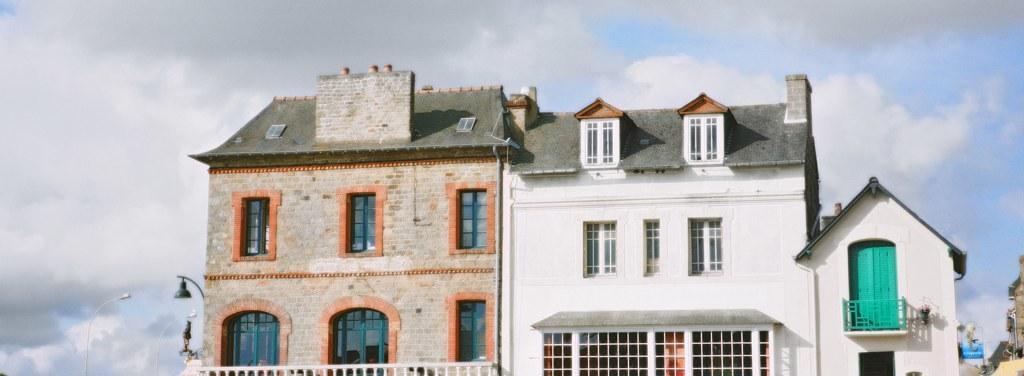In one or two sentences, can you explain what this image depicts? In this image I can see a building along with the windows. On the left side there are few light poles. On the right side there are some more buildings. At the top of the image I can see the sky. 